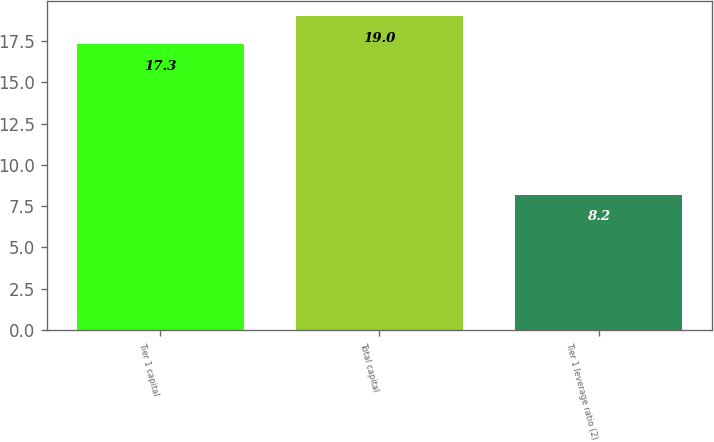Convert chart to OTSL. <chart><loc_0><loc_0><loc_500><loc_500><bar_chart><fcel>Tier 1 capital<fcel>Total capital<fcel>Tier 1 leverage ratio (2)<nl><fcel>17.3<fcel>19<fcel>8.2<nl></chart> 